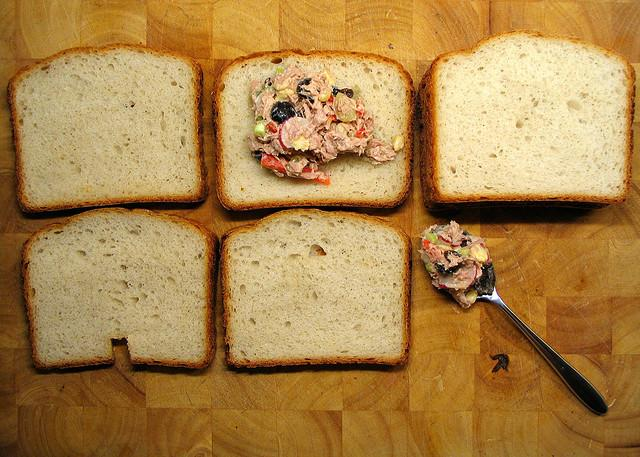How many slices of bread will filling be put on?

Choices:
A) two
B) four
C) three
D) six three 